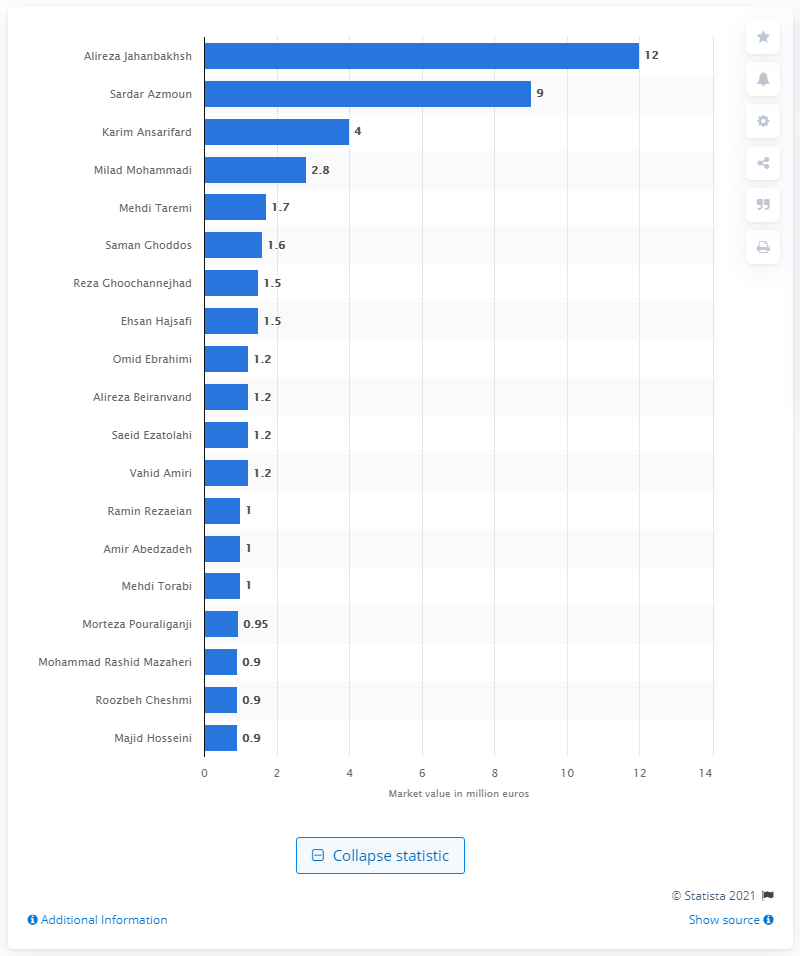Draw attention to some important aspects in this diagram. The most valuable player at the 2018 FIFA World Cup was Alireza Jahanbakhsh. The market value of Alireza Jahanbakhsh was 12.. 